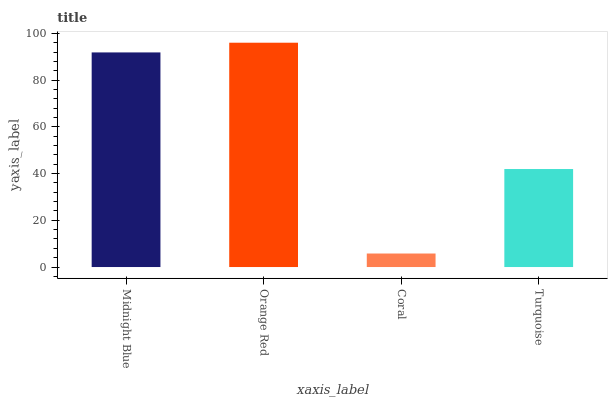Is Coral the minimum?
Answer yes or no. Yes. Is Orange Red the maximum?
Answer yes or no. Yes. Is Orange Red the minimum?
Answer yes or no. No. Is Coral the maximum?
Answer yes or no. No. Is Orange Red greater than Coral?
Answer yes or no. Yes. Is Coral less than Orange Red?
Answer yes or no. Yes. Is Coral greater than Orange Red?
Answer yes or no. No. Is Orange Red less than Coral?
Answer yes or no. No. Is Midnight Blue the high median?
Answer yes or no. Yes. Is Turquoise the low median?
Answer yes or no. Yes. Is Turquoise the high median?
Answer yes or no. No. Is Midnight Blue the low median?
Answer yes or no. No. 